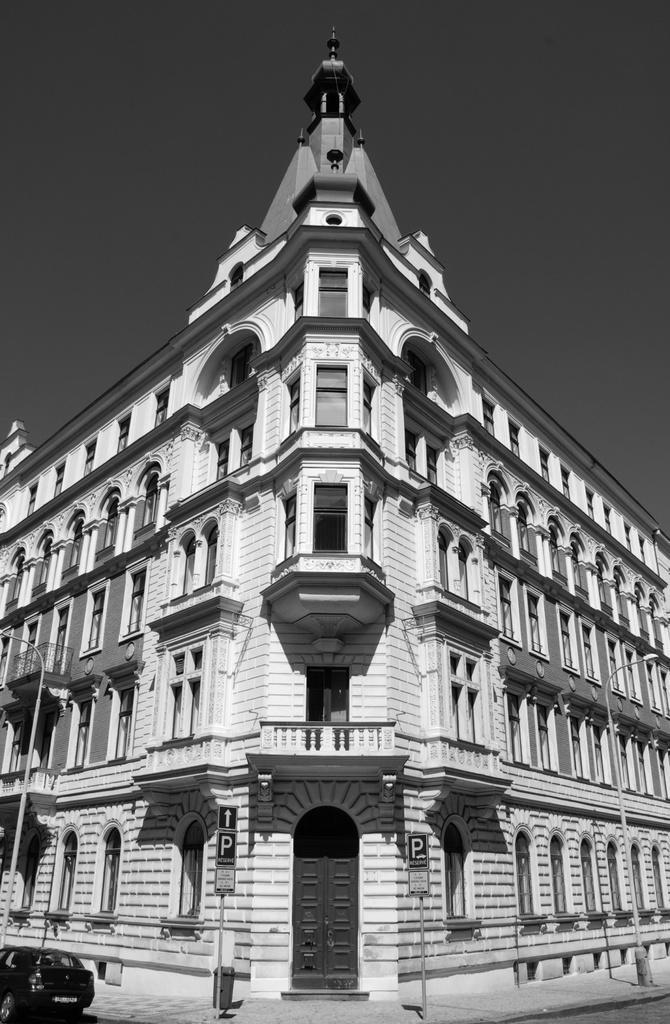Describe this image in one or two sentences. In the center of the picture there is a building we can see windows and door to the buildings. At the top it is sky. In the foreground we can see boards, poles, footpath, road and a car. 